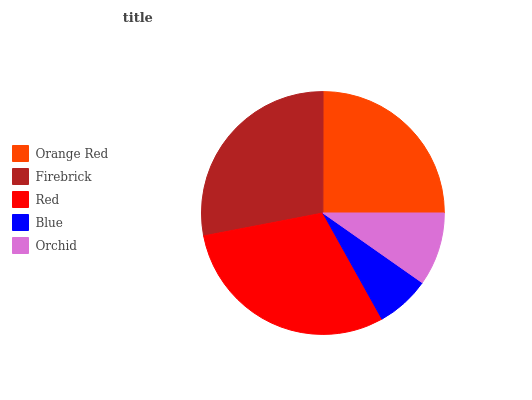Is Blue the minimum?
Answer yes or no. Yes. Is Red the maximum?
Answer yes or no. Yes. Is Firebrick the minimum?
Answer yes or no. No. Is Firebrick the maximum?
Answer yes or no. No. Is Firebrick greater than Orange Red?
Answer yes or no. Yes. Is Orange Red less than Firebrick?
Answer yes or no. Yes. Is Orange Red greater than Firebrick?
Answer yes or no. No. Is Firebrick less than Orange Red?
Answer yes or no. No. Is Orange Red the high median?
Answer yes or no. Yes. Is Orange Red the low median?
Answer yes or no. Yes. Is Red the high median?
Answer yes or no. No. Is Firebrick the low median?
Answer yes or no. No. 